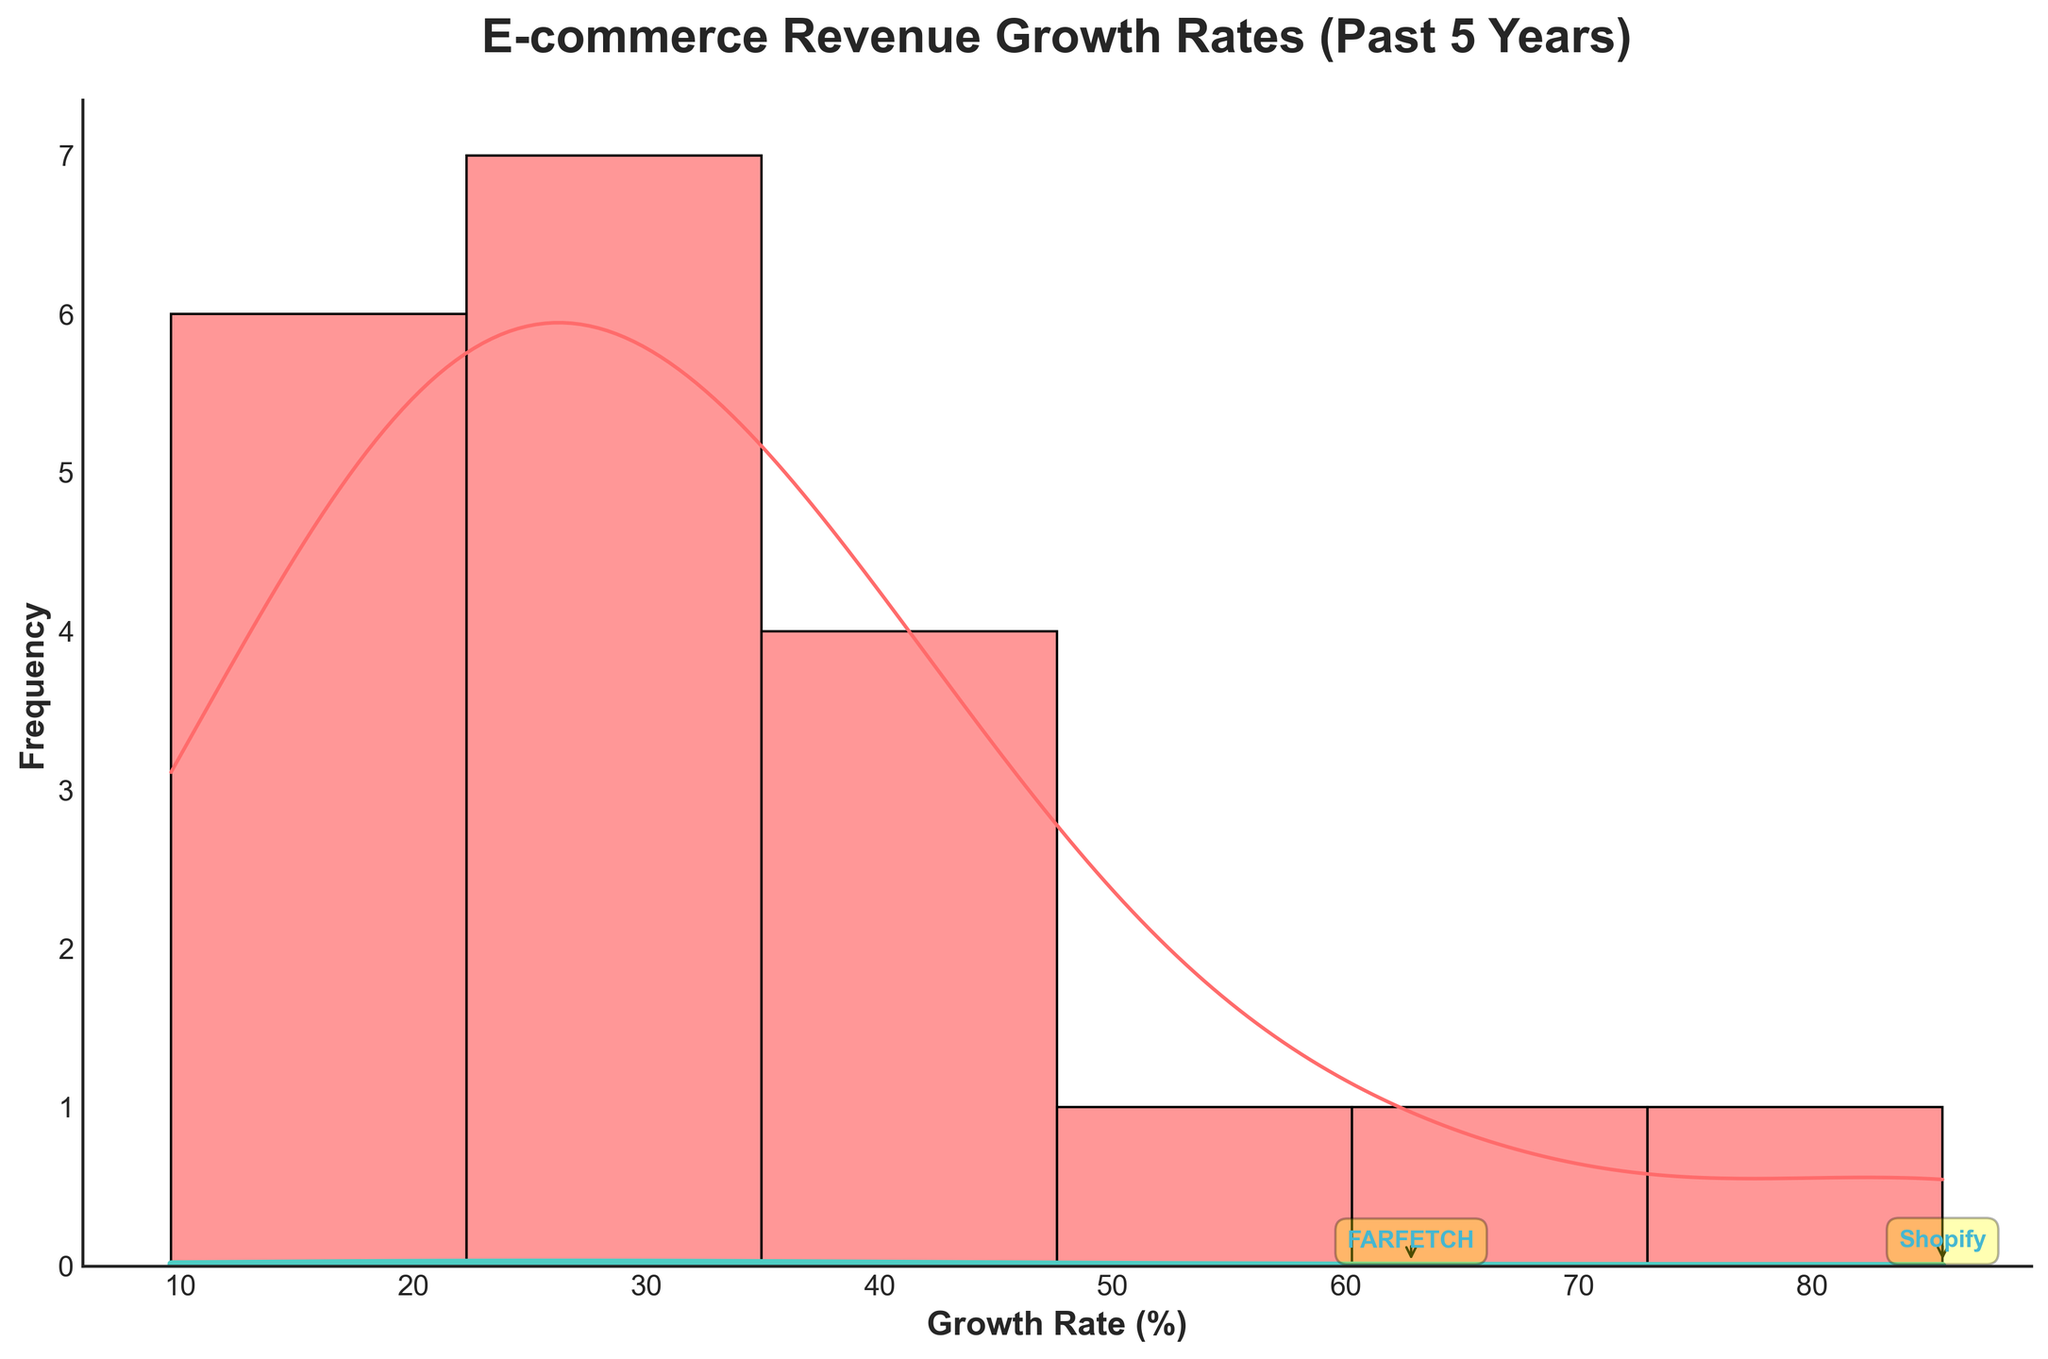What's the title of the figure? The title is displayed at the top of the figure and reads "E-commerce Revenue Growth Rates (Past 5 Years)".
Answer: "E-commerce Revenue Growth Rates (Past 5 Years)" What are the x-axis and y-axis labels? The x-axis label is "Growth Rate (%)" and the y-axis label is "Frequency". These labels are shown below and to the left of the respective axes.
Answer: Growth Rate (%), Frequency How many companies have a growth rate higher than 60%? By examining the annotations and the histogram, there are two companies that have growth rates higher than 60%; Shopify and FARFETCH have annotations indicating their high growth rates.
Answer: 2 Which company has the highest revenue growth rate, and what is it? By looking at the annotations on the histogram, Shopify has the highest revenue growth rate at 85.6%.
Answer: Shopify, 85.6% Which company has the lowest growth rate, and what is it? Observing the histogram, Newegg has the lowest growth rate, with an annotation pointing to a rate of 9.6%.
Answer: Newegg, 9.6% What is the general shape of the KDE curve? The KDE curve provides an estimate of the density distribution. It is smooth and forms a unimodal peak, indicating that most companies have growth rates around a central value.
Answer: Unimodal Compare the growth rate of Amazon to Alibaba. Which company has a higher rate? Look at the placement on the histogram: Amazon's rate is 22.5%, while Alibaba's rate is 38.9%. Therefore, Alibaba has a higher growth rate.
Answer: Alibaba How does the range of growth rates compare between the different companies? By observing the x-axis range, the growth rates range from about 9.6% (for Newegg) to 85.6% (for Shopify), showing a wide variability among e-commerce companies.
Answer: 9.6% to 85.6% Which companies are annotated and what characteristic do they share? The annotations highlight companies with growth rates above 60%: Shopify and FARFETCH. This characteristic indicates that they are significant outliers in growth rate compared to other companies.
Answer: Shopify, FARFETCH 